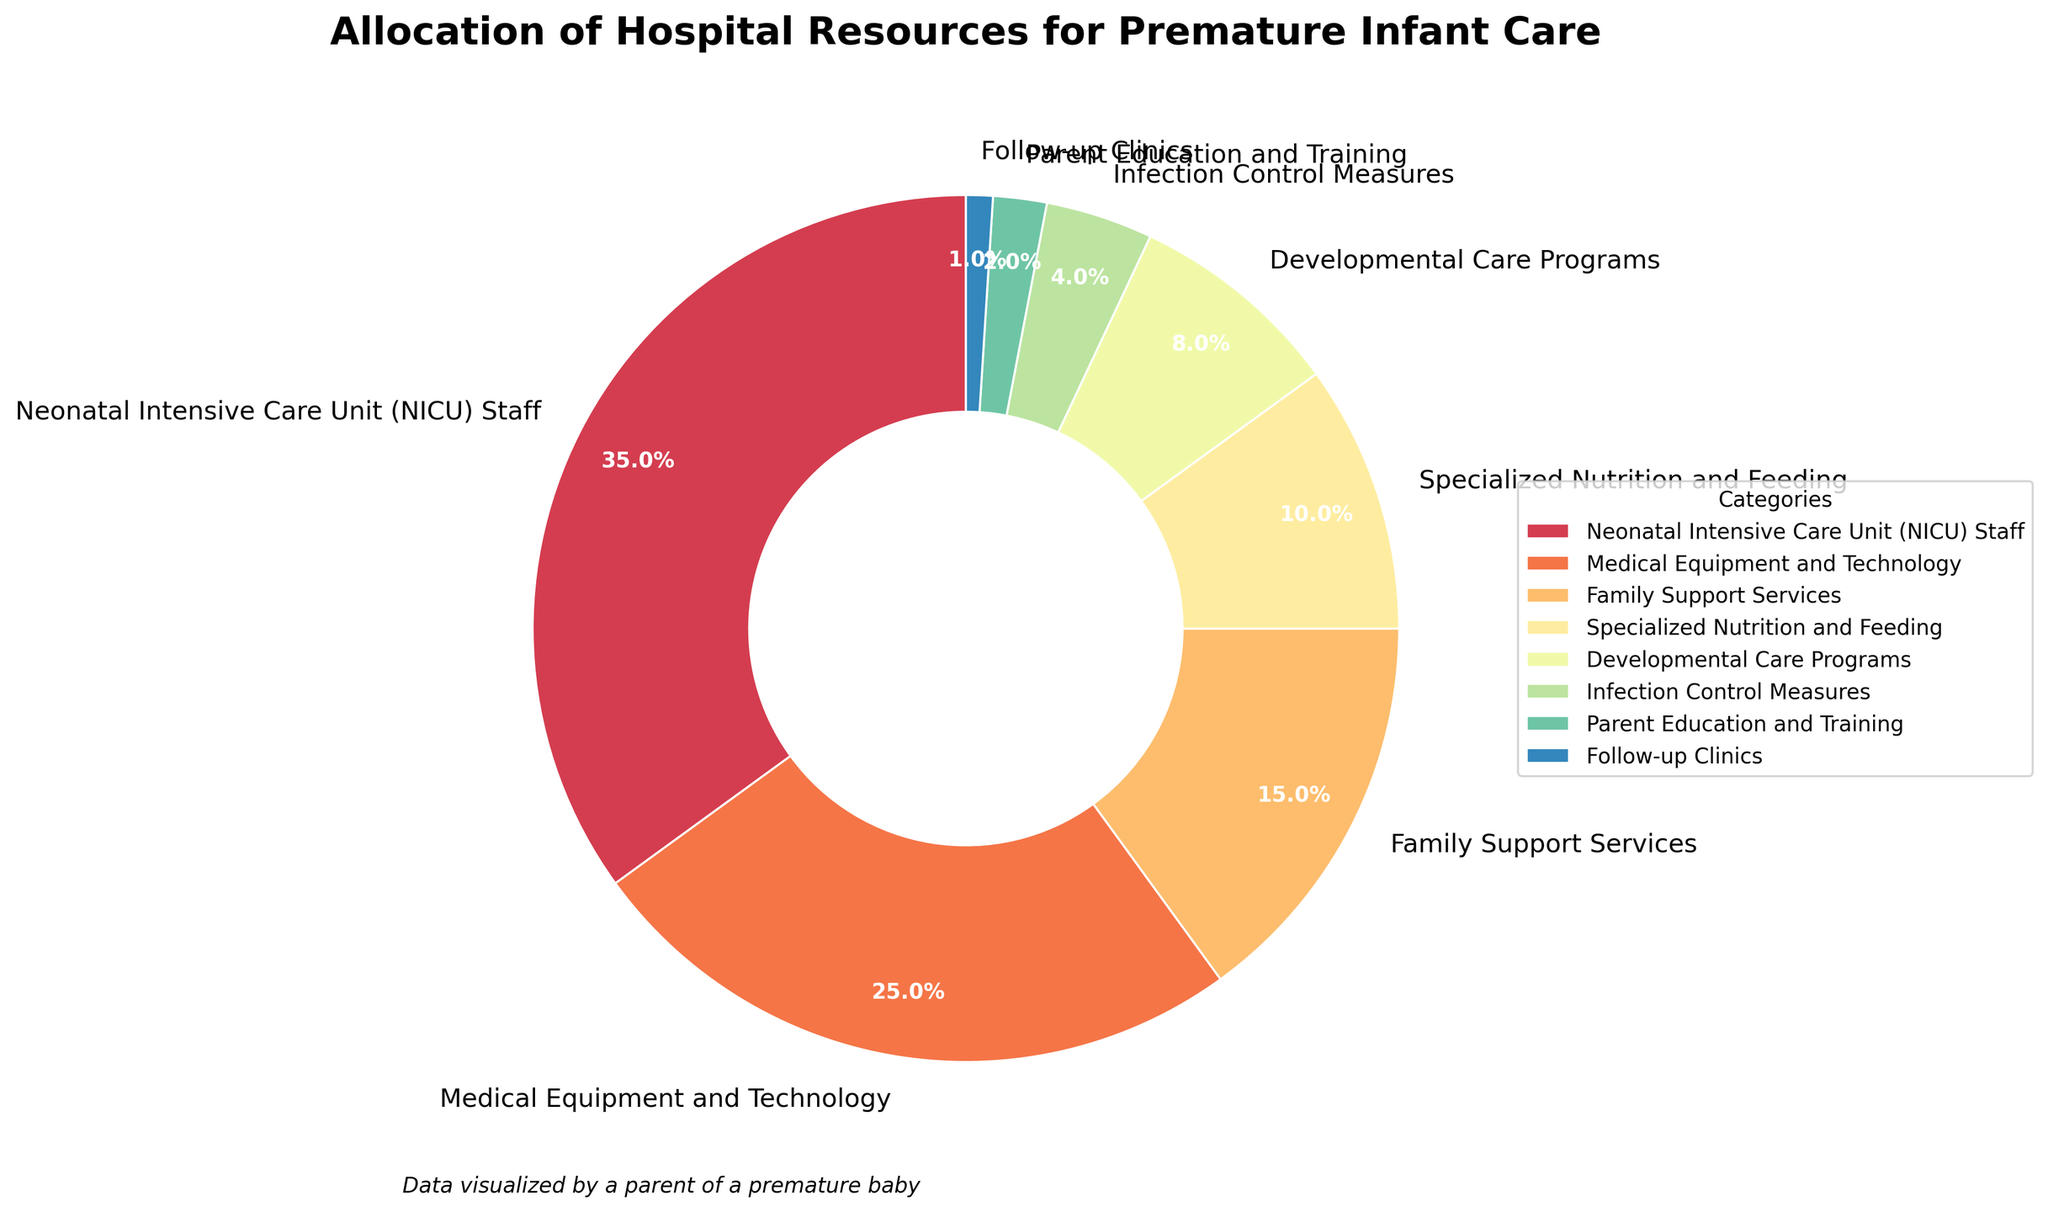How much combined percentage is allocated for Family Support Services, Specialized Nutrition and Feeding, and Developmental Care Programs? To find the combined percentage, add the percentages for Family Support Services (15%), Specialized Nutrition and Feeding (10%), and Developmental Care Programs (8%). 15 + 10 + 8 = 33
Answer: 33 Which category has the highest allocated percentage? Look for the category with the largest slice in the pie chart. That is the segment labeled 'Neonatal Intensive Care Unit (NICU) Staff' which is 35%.
Answer: Neonatal Intensive Care Unit (NICU) Staff Is the percentage for Medical Equipment and Technology greater than the combined percentage for Infection Control Measures, Parent Education and Training, and Follow-up Clinics? The percentage for Medical Equipment and Technology is 25%. The combined percentage for Infection Control Measures (4%), Parent Education and Training (2%), and Follow-up Clinics (1%) is 4 + 2 + 1 = 7%. Since 25% is greater than 7%, the answer is yes.
Answer: Yes Which category has the smallest slice in the pie chart? Identify the segment with the smallest area in the pie chart. That would be the 'Follow-up Clinics' which has 1%.
Answer: Follow-up Clinics What is the difference in percentage allocation between NICU Staff and Specialized Nutrition and Feeding? Subtract the percentage of Specialized Nutrition and Feeding (10%) from NICU Staff (35%). 35 - 10 = 25
Answer: 25 How many categories have a percentage allocation greater than 10%? Count the slices in the pie chart with percentages greater than 10%. Those are NICU Staff (35%), Medical Equipment and Technology (25%), and Family Support Services (15%). There are 3 such categories.
Answer: 3 What visual color is used for Developmental Care Programs in the pie chart? Observe the color assigned to Developmental Care Programs which occupies 8% of the chart. The color might vary based on the Spectral colormap but in a detailed pie chart description, we see it takes a differentiable color for easy identification.
Answer: Varies (depends on visualization but likely a unique color in the Spectral scheme) Is the percentage allocated to NICU Staff more than double the percentage allocated to Family Support Services? NICU Staff is allocated 35% while Family Support Services is allocated 15%. Check if 35% is more than double of 15% which is 30% (15 * 2). Since 35% is more than 30%, the answer is yes.
Answer: Yes What is the median percentage of all the categories listed? List all the percentages in order: 1%, 2%, 4%, 8%, 10%, 15%, 25%, 35%. With 8 values, the median will be the average of the 4th and 5th values. The 4th and 5th values are (8% and 10%), so the median is (8 + 10) / 2 = 9
Answer: 9 